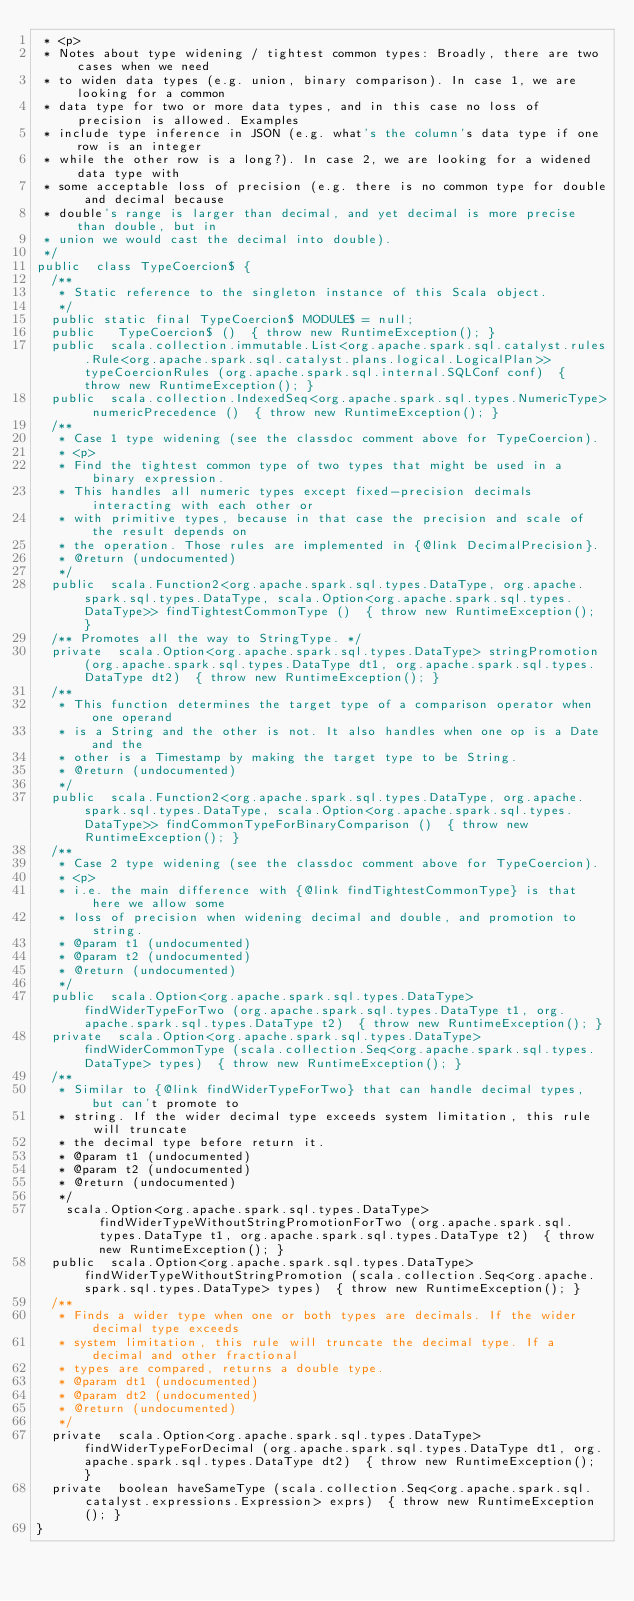<code> <loc_0><loc_0><loc_500><loc_500><_Java_> * <p>
 * Notes about type widening / tightest common types: Broadly, there are two cases when we need
 * to widen data types (e.g. union, binary comparison). In case 1, we are looking for a common
 * data type for two or more data types, and in this case no loss of precision is allowed. Examples
 * include type inference in JSON (e.g. what's the column's data type if one row is an integer
 * while the other row is a long?). In case 2, we are looking for a widened data type with
 * some acceptable loss of precision (e.g. there is no common type for double and decimal because
 * double's range is larger than decimal, and yet decimal is more precise than double, but in
 * union we would cast the decimal into double).
 */
public  class TypeCoercion$ {
  /**
   * Static reference to the singleton instance of this Scala object.
   */
  public static final TypeCoercion$ MODULE$ = null;
  public   TypeCoercion$ ()  { throw new RuntimeException(); }
  public  scala.collection.immutable.List<org.apache.spark.sql.catalyst.rules.Rule<org.apache.spark.sql.catalyst.plans.logical.LogicalPlan>> typeCoercionRules (org.apache.spark.sql.internal.SQLConf conf)  { throw new RuntimeException(); }
  public  scala.collection.IndexedSeq<org.apache.spark.sql.types.NumericType> numericPrecedence ()  { throw new RuntimeException(); }
  /**
   * Case 1 type widening (see the classdoc comment above for TypeCoercion).
   * <p>
   * Find the tightest common type of two types that might be used in a binary expression.
   * This handles all numeric types except fixed-precision decimals interacting with each other or
   * with primitive types, because in that case the precision and scale of the result depends on
   * the operation. Those rules are implemented in {@link DecimalPrecision}.
   * @return (undocumented)
   */
  public  scala.Function2<org.apache.spark.sql.types.DataType, org.apache.spark.sql.types.DataType, scala.Option<org.apache.spark.sql.types.DataType>> findTightestCommonType ()  { throw new RuntimeException(); }
  /** Promotes all the way to StringType. */
  private  scala.Option<org.apache.spark.sql.types.DataType> stringPromotion (org.apache.spark.sql.types.DataType dt1, org.apache.spark.sql.types.DataType dt2)  { throw new RuntimeException(); }
  /**
   * This function determines the target type of a comparison operator when one operand
   * is a String and the other is not. It also handles when one op is a Date and the
   * other is a Timestamp by making the target type to be String.
   * @return (undocumented)
   */
  public  scala.Function2<org.apache.spark.sql.types.DataType, org.apache.spark.sql.types.DataType, scala.Option<org.apache.spark.sql.types.DataType>> findCommonTypeForBinaryComparison ()  { throw new RuntimeException(); }
  /**
   * Case 2 type widening (see the classdoc comment above for TypeCoercion).
   * <p>
   * i.e. the main difference with {@link findTightestCommonType} is that here we allow some
   * loss of precision when widening decimal and double, and promotion to string.
   * @param t1 (undocumented)
   * @param t2 (undocumented)
   * @return (undocumented)
   */
  public  scala.Option<org.apache.spark.sql.types.DataType> findWiderTypeForTwo (org.apache.spark.sql.types.DataType t1, org.apache.spark.sql.types.DataType t2)  { throw new RuntimeException(); }
  private  scala.Option<org.apache.spark.sql.types.DataType> findWiderCommonType (scala.collection.Seq<org.apache.spark.sql.types.DataType> types)  { throw new RuntimeException(); }
  /**
   * Similar to {@link findWiderTypeForTwo} that can handle decimal types, but can't promote to
   * string. If the wider decimal type exceeds system limitation, this rule will truncate
   * the decimal type before return it.
   * @param t1 (undocumented)
   * @param t2 (undocumented)
   * @return (undocumented)
   */
    scala.Option<org.apache.spark.sql.types.DataType> findWiderTypeWithoutStringPromotionForTwo (org.apache.spark.sql.types.DataType t1, org.apache.spark.sql.types.DataType t2)  { throw new RuntimeException(); }
  public  scala.Option<org.apache.spark.sql.types.DataType> findWiderTypeWithoutStringPromotion (scala.collection.Seq<org.apache.spark.sql.types.DataType> types)  { throw new RuntimeException(); }
  /**
   * Finds a wider type when one or both types are decimals. If the wider decimal type exceeds
   * system limitation, this rule will truncate the decimal type. If a decimal and other fractional
   * types are compared, returns a double type.
   * @param dt1 (undocumented)
   * @param dt2 (undocumented)
   * @return (undocumented)
   */
  private  scala.Option<org.apache.spark.sql.types.DataType> findWiderTypeForDecimal (org.apache.spark.sql.types.DataType dt1, org.apache.spark.sql.types.DataType dt2)  { throw new RuntimeException(); }
  private  boolean haveSameType (scala.collection.Seq<org.apache.spark.sql.catalyst.expressions.Expression> exprs)  { throw new RuntimeException(); }
}
</code> 